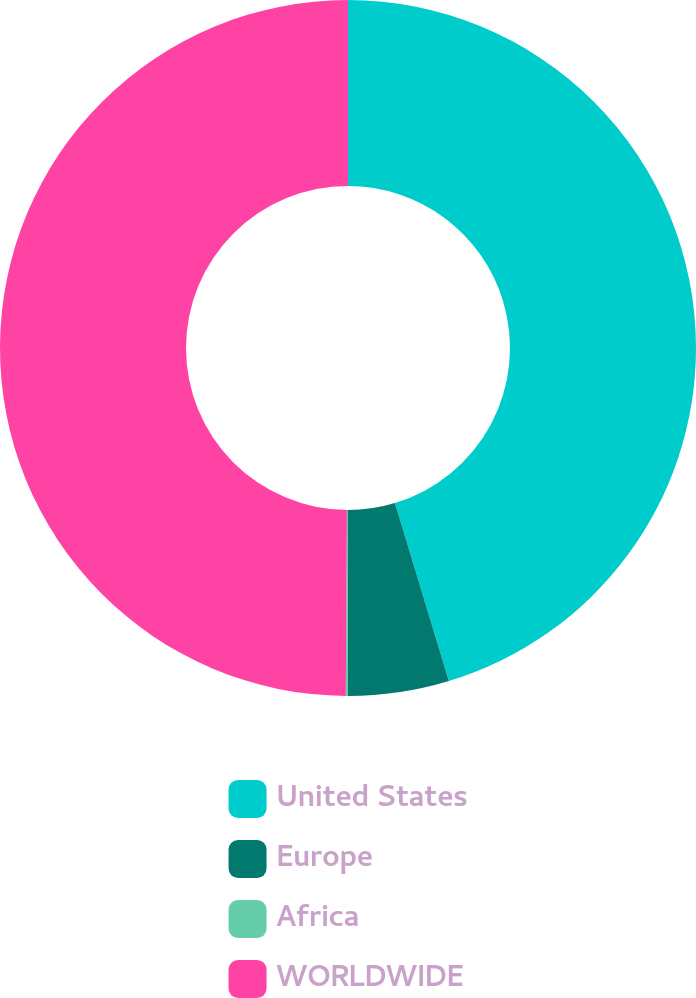Convert chart to OTSL. <chart><loc_0><loc_0><loc_500><loc_500><pie_chart><fcel>United States<fcel>Europe<fcel>Africa<fcel>WORLDWIDE<nl><fcel>45.32%<fcel>4.68%<fcel>0.1%<fcel>49.9%<nl></chart> 